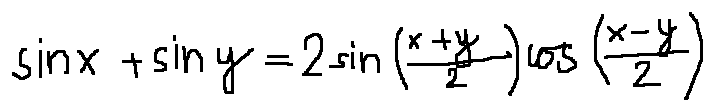Convert formula to latex. <formula><loc_0><loc_0><loc_500><loc_500>\sin x + \sin y = 2 \sin ( \frac { x + y } { 2 } ) \cos ( \frac { x - y } { 2 } )</formula> 